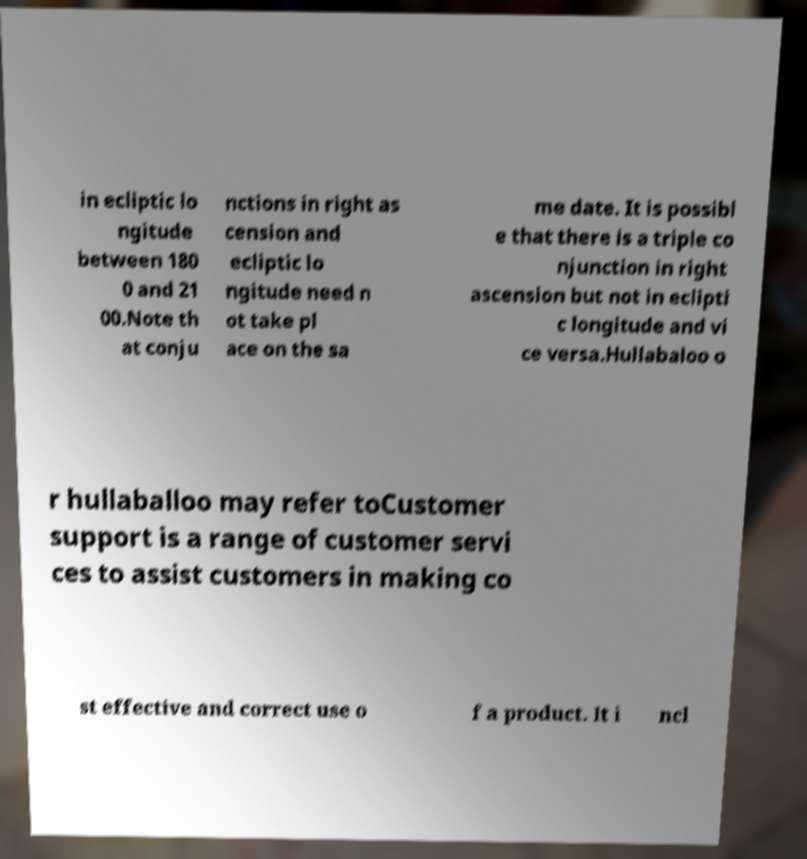Please identify and transcribe the text found in this image. in ecliptic lo ngitude between 180 0 and 21 00.Note th at conju nctions in right as cension and ecliptic lo ngitude need n ot take pl ace on the sa me date. It is possibl e that there is a triple co njunction in right ascension but not in eclipti c longitude and vi ce versa.Hullabaloo o r hullaballoo may refer toCustomer support is a range of customer servi ces to assist customers in making co st effective and correct use o f a product. It i ncl 